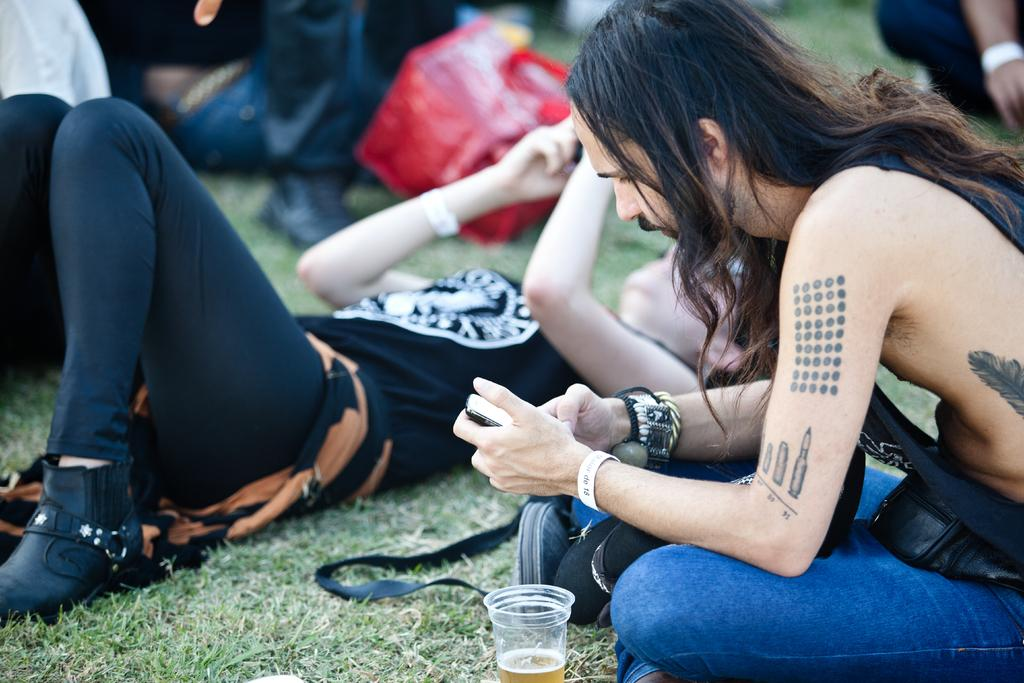What object can be seen in the image that is typically used for drinking? There is a glass in the image that is typically used for drinking. What is the people's position in the image? The people are sitting and lying on the grass in the image. What is the color of the grass in the image? The grass is green in the image. What are the people holding in their hands? The people are holding mobiles in their hands in the image. Is the grass in the image actually quicksand, and are the people sinking into it? No, the grass in the image is not quicksand, and the people are not sinking into it. The grass is green, and the people are sitting and lying on it. 